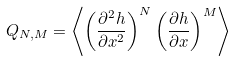Convert formula to latex. <formula><loc_0><loc_0><loc_500><loc_500>Q _ { N , M } = \left \langle \left ( \frac { \partial ^ { 2 } h } { \partial x ^ { 2 } } \right ) ^ { N } \left ( \frac { \partial h } { \partial x } \right ) ^ { M } \right \rangle</formula> 